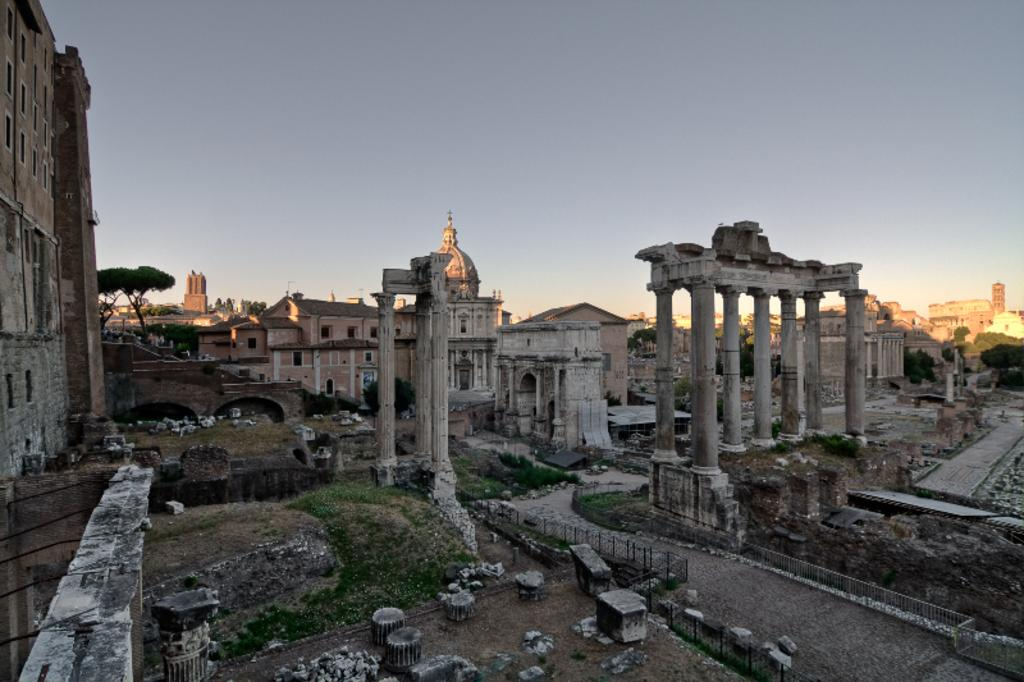What type of structures can be seen in the image? There are buildings in the image. What type of vegetation is visible in the image? There is grass visible in the image. What other natural elements can be seen in the image? There are trees in the image. What is visible in the background of the image? The sky is visible in the background of the image. What type of arch can be seen in the image? There is no arch present in the image. How many points are visible on the trees in the image? Trees do not have points; they have branches and leaves. 